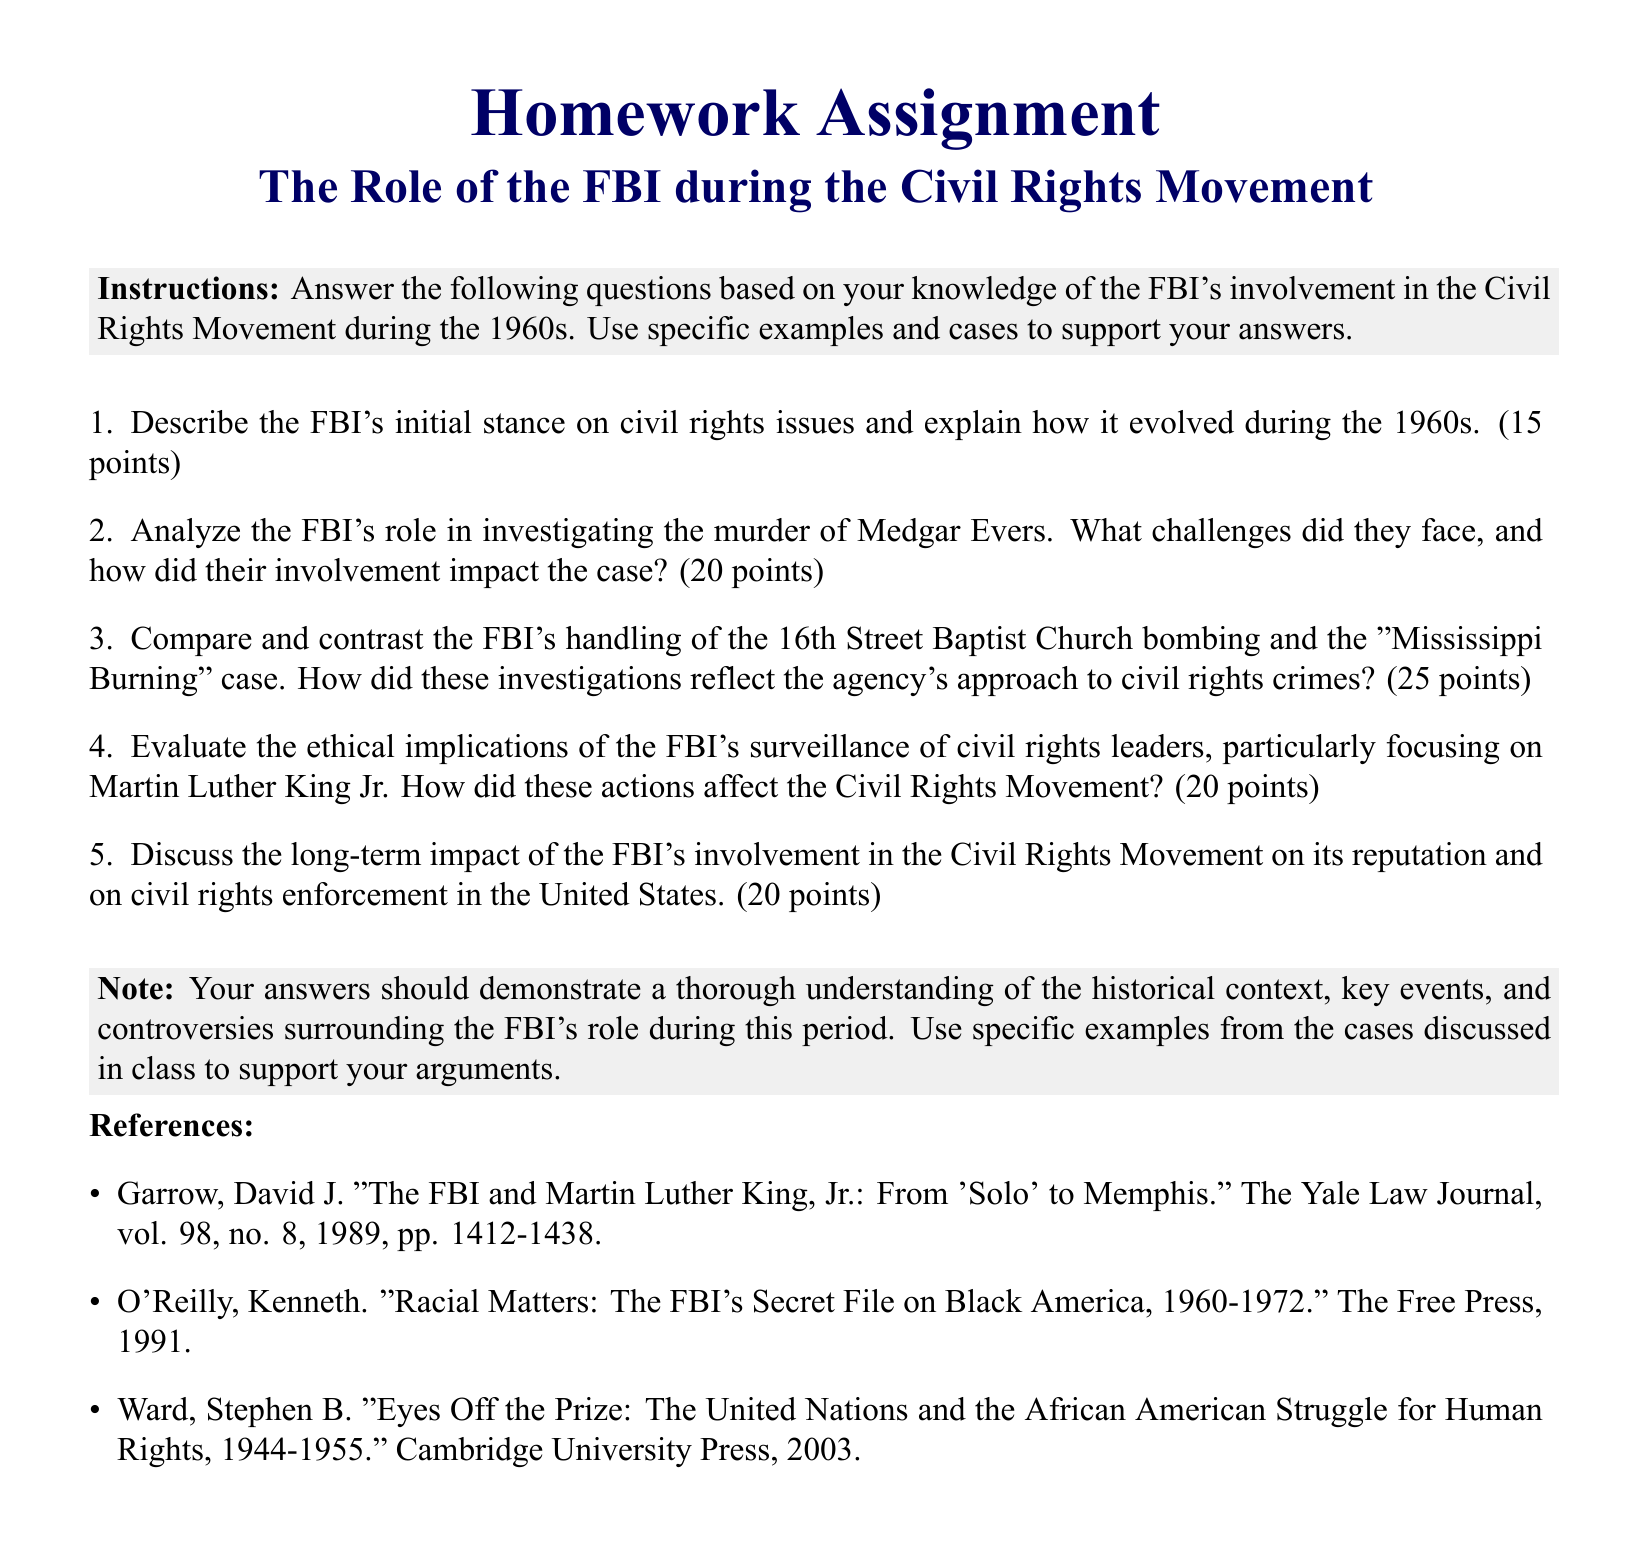What is the title of the homework assignment? The title of the homework assignment is clearly stated in the document, which is about the role of the FBI during the Civil Rights Movement.
Answer: The Role of the FBI during the Civil Rights Movement How many points is the question about the FBI's role in investigating the murder of Medgar Evers worth? The points allocated for the question regarding the investigation of Medgar Evers are specifically mentioned in the document.
Answer: 20 points Who is one civil rights leader that the FBI surveilled? The document refers to Martin Luther King Jr. as a specific civil rights leader whose actions were monitored by the FBI.
Answer: Martin Luther King Jr What is the total number of questions in the assignment? The document lists five questions in total, each focused on various aspects of the FBI's involvement during the Civil Rights Movement.
Answer: 5 Which case is compared to the 16th Street Baptist Church bombing in the assignment? The document asks for a comparison with the "Mississippi Burning" case in the context of how the FBI handled civil rights crimes.
Answer: Mississippi Burning What is the required format for the answers according to the document's instructions? The document instructs students to demonstrate understanding of historical context and to use specific examples from discussed cases in their answers.
Answer: Specific examples What is the color of the background used for the instructions box? The background color of the instructions box is defined in the document as light gray.
Answer: Light gray 